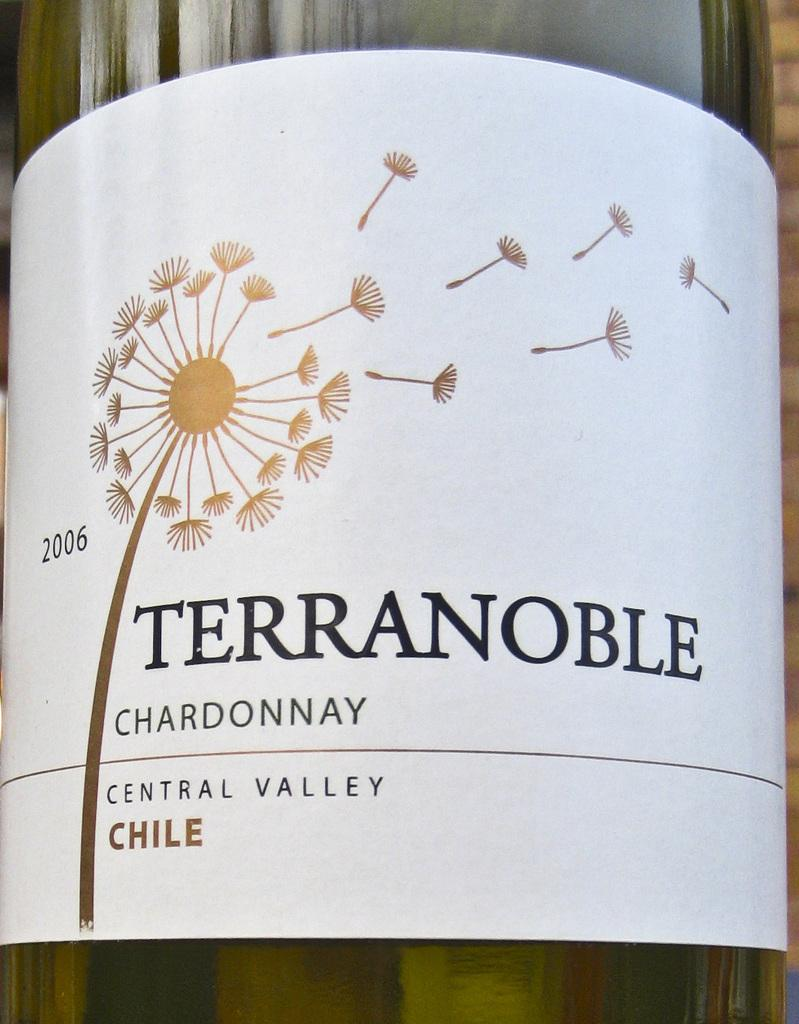<image>
Summarize the visual content of the image. A bottle of Terranoble Chardonnary is from Chile. 